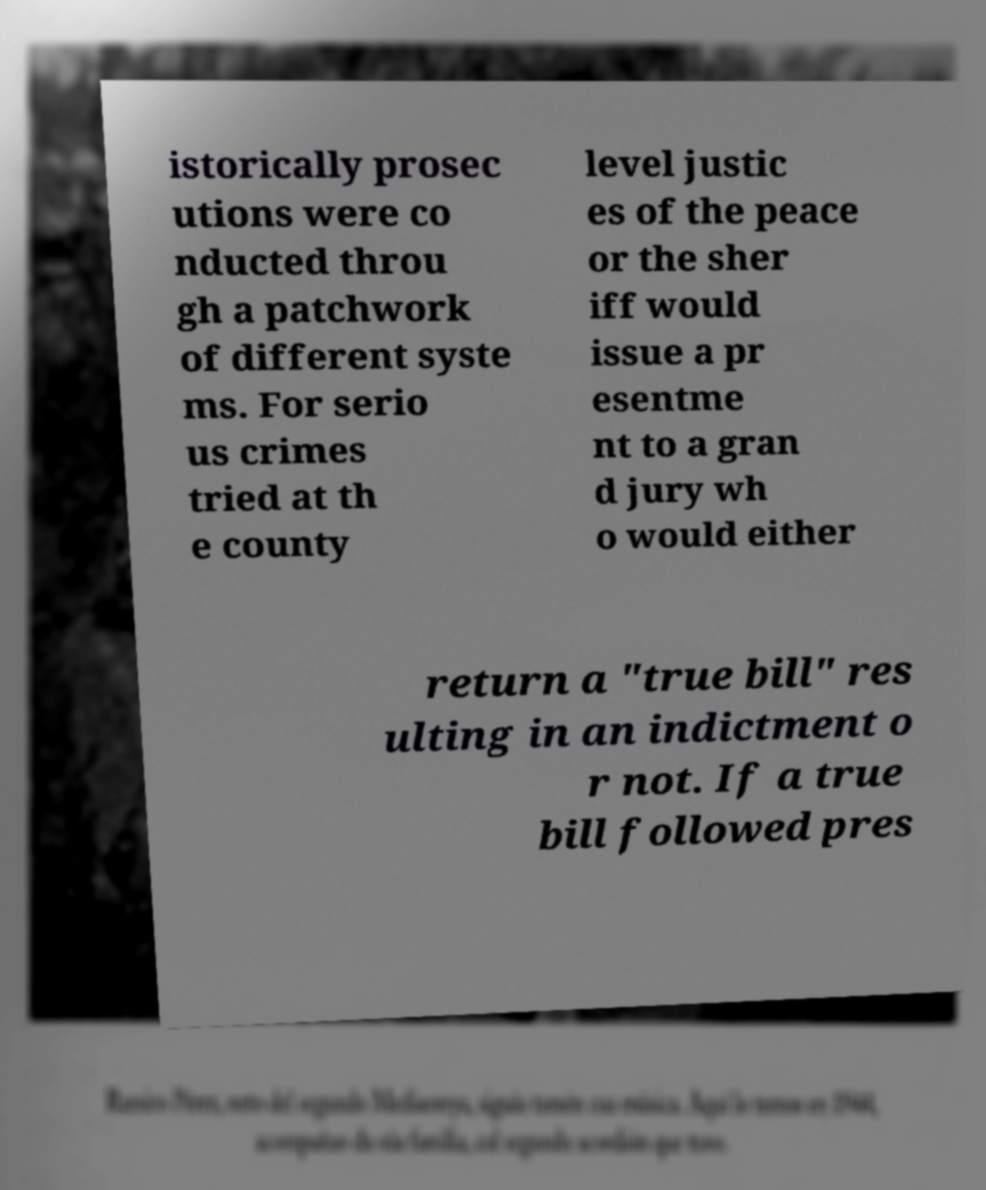Please read and relay the text visible in this image. What does it say? istorically prosec utions were co nducted throu gh a patchwork of different syste ms. For serio us crimes tried at th e county level justic es of the peace or the sher iff would issue a pr esentme nt to a gran d jury wh o would either return a "true bill" res ulting in an indictment o r not. If a true bill followed pres 